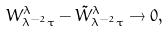<formula> <loc_0><loc_0><loc_500><loc_500>W _ { \lambda ^ { - 2 } \tau } ^ { \lambda } - \tilde { W } _ { \lambda ^ { - 2 } \tau } ^ { \lambda } \to 0 ,</formula> 